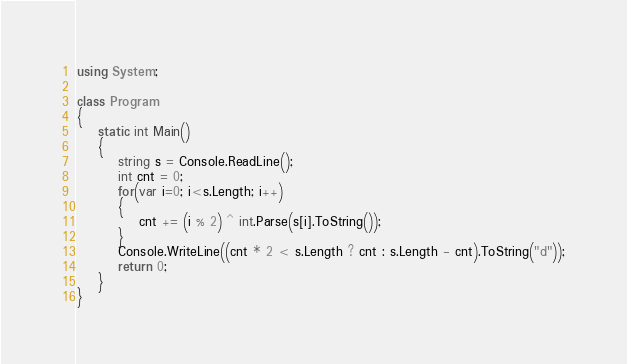Convert code to text. <code><loc_0><loc_0><loc_500><loc_500><_C#_>using System;

class Program
{
    static int Main()
    {
        string s = Console.ReadLine();
        int cnt = 0;
        for(var i=0; i<s.Length; i++)
        {
            cnt += (i % 2) ^ int.Parse(s[i].ToString());
        }
        Console.WriteLine((cnt * 2 < s.Length ? cnt : s.Length - cnt).ToString("d"));
        return 0;
    }
}</code> 